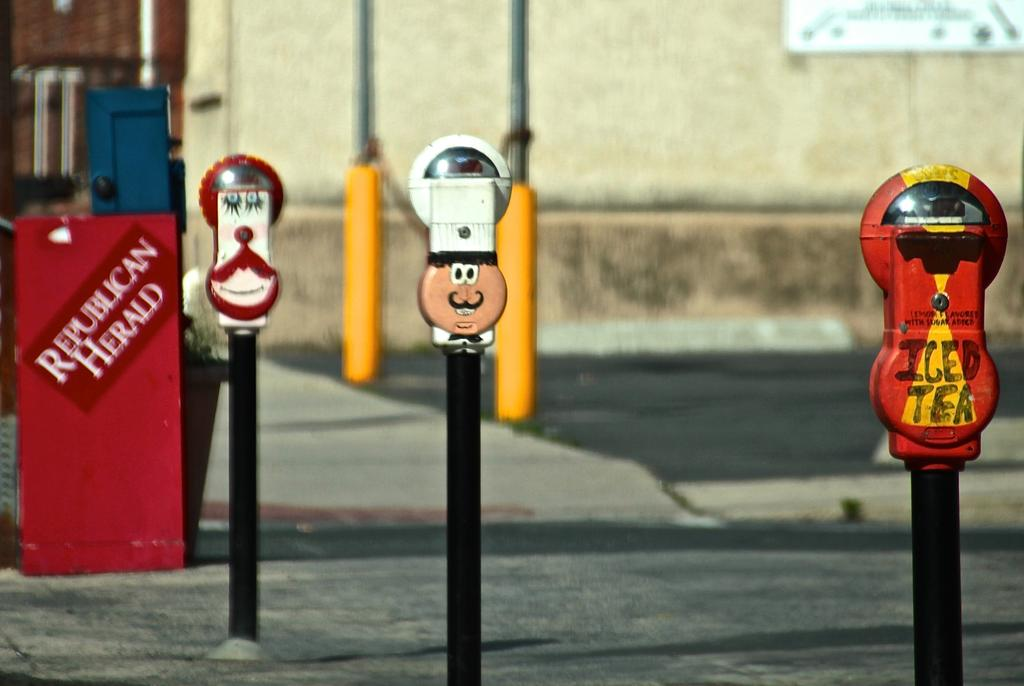Provide a one-sentence caption for the provided image. Several funny parking meters are installed near a Republican Herald newspaper box. 